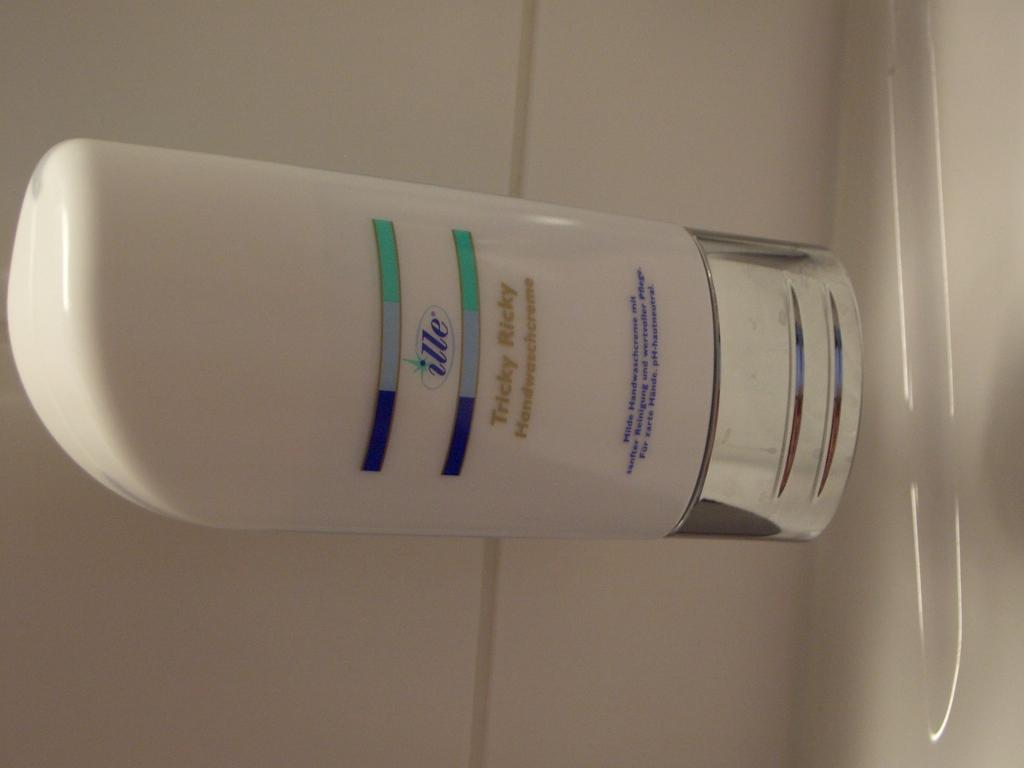Provide a one-sentence caption for the provided image. A white bottle of Ille hand soap sits on a white surface. 